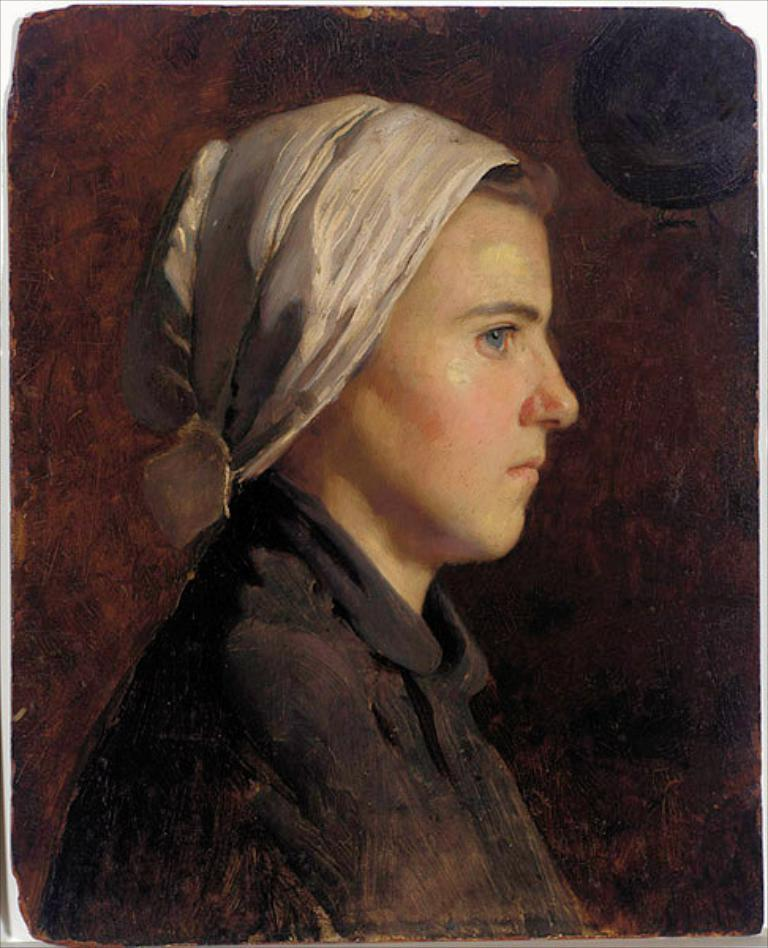What is the main subject of the image? The main subject of the image is a painting. What does the painting depict? The painting depicts a person. What color is the background of the painting? The background of the painting is brown. How does the painting balance itself on the edge of the table in the image? The painting does not balance itself on the edge of the table in the image; it is likely hanging on a wall or placed on a surface. 